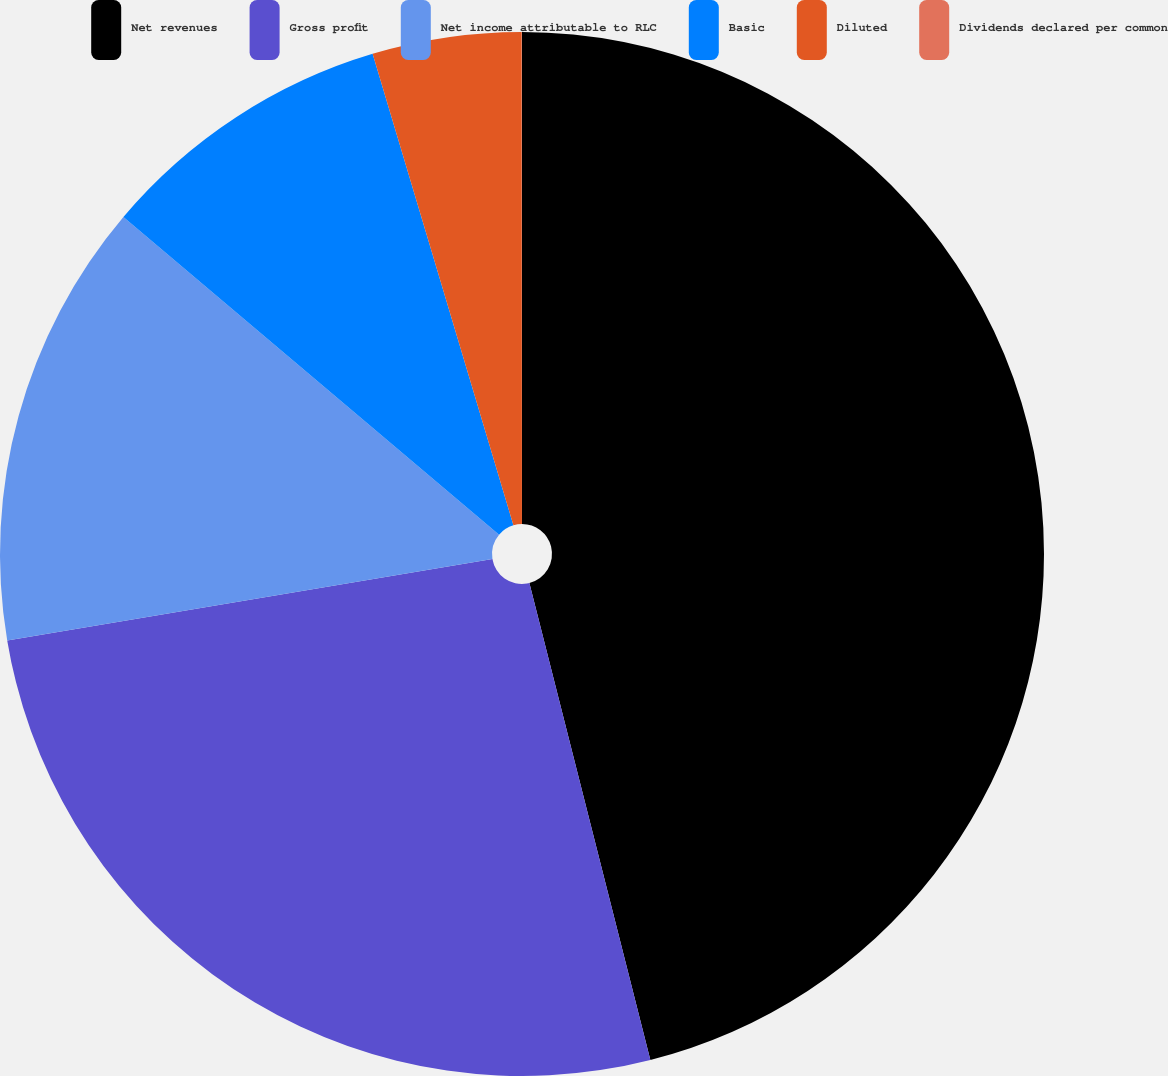<chart> <loc_0><loc_0><loc_500><loc_500><pie_chart><fcel>Net revenues<fcel>Gross profit<fcel>Net income attributable to RLC<fcel>Basic<fcel>Diluted<fcel>Dividends declared per common<nl><fcel>46.05%<fcel>26.31%<fcel>13.82%<fcel>9.21%<fcel>4.61%<fcel>0.01%<nl></chart> 